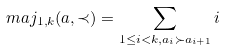<formula> <loc_0><loc_0><loc_500><loc_500>\ m a j _ { 1 , k } ( a , \prec ) = \sum _ { 1 \leq i < k , a _ { i } \succ a _ { i + 1 } } i</formula> 